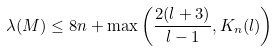<formula> <loc_0><loc_0><loc_500><loc_500>\lambda ( M ) \leq 8 n + \max \left ( \frac { 2 ( l + 3 ) } { l - 1 } , K _ { n } ( l ) \right )</formula> 